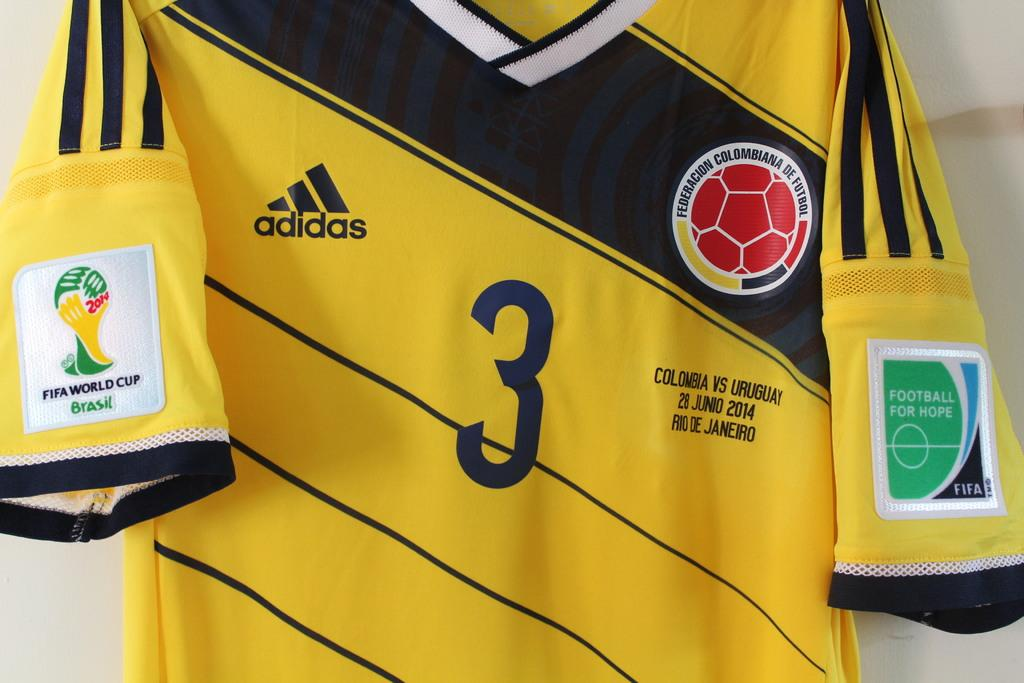<image>
Give a short and clear explanation of the subsequent image. a yellow and blue adidas shirt with number 3 on the front. 